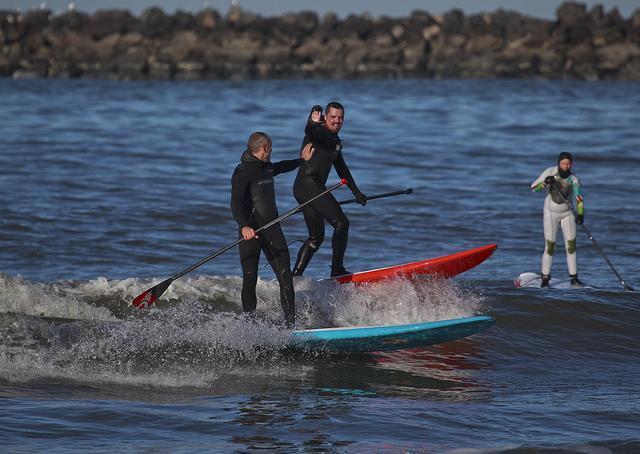How many people are on the water?
Give a very brief answer. 3. How many surfboards can you see?
Give a very brief answer. 2. How many people are there?
Give a very brief answer. 3. How many solid black cats on the chair?
Give a very brief answer. 0. 